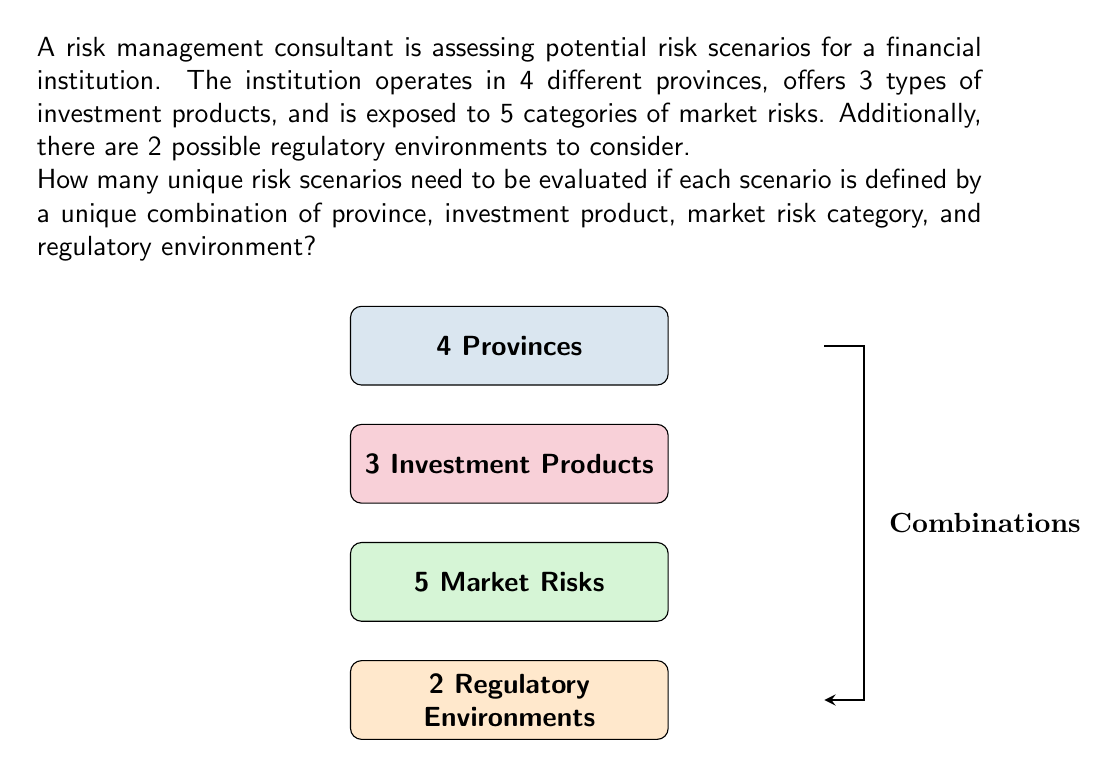Can you answer this question? To solve this problem, we'll use the multiplication principle of counting. This principle states that if we have a series of independent choices, the total number of possible outcomes is the product of the number of possibilities for each choice.

Let's break down the factors:
1. Number of provinces: 4
2. Number of investment products: 3
3. Number of market risk categories: 5
4. Number of regulatory environments: 2

Each risk scenario is uniquely defined by choosing one option from each of these factors. Therefore, we multiply these numbers together to get the total number of possible risk scenarios:

$$ \text{Total Scenarios} = 4 \times 3 \times 5 \times 2 $$

Calculating this:
$$ \text{Total Scenarios} = 120 $$

This means that the risk management consultant needs to evaluate 120 unique risk scenarios to cover all possible combinations of the given factors.

This approach ensures a comprehensive risk assessment, considering every possible interaction between the different elements that could affect the financial institution's risk profile.
Answer: 120 unique risk scenarios 